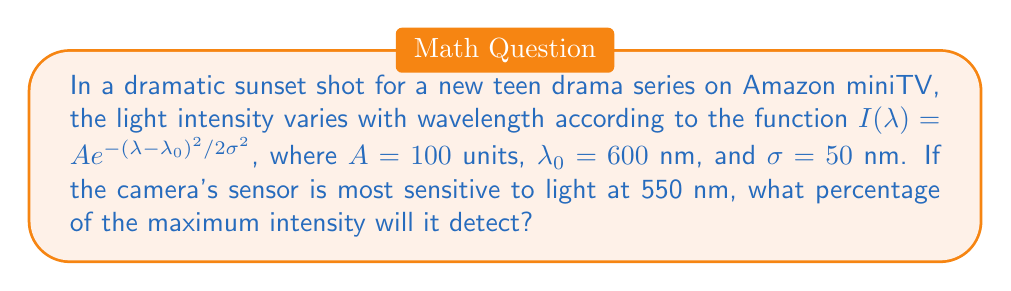Provide a solution to this math problem. Let's approach this step-by-step:

1) The light intensity function is given by:
   $$I(\lambda) = A e^{-(\lambda - \lambda_0)^2 / 2\sigma^2}$$

2) We're given:
   $A = 100$ units
   $\lambda_0 = 600$ nm
   $\sigma = 50$ nm

3) The camera is most sensitive at $\lambda = 550$ nm

4) To find the intensity at 550 nm, we substitute these values into the equation:
   $$I(550) = 100 e^{-(550 - 600)^2 / 2(50)^2}$$

5) Simplify inside the exponent:
   $$I(550) = 100 e^{-(-50)^2 / 2(2500)}$$
   $$I(550) = 100 e^{-2500 / 5000}$$
   $$I(550) = 100 e^{-0.5}$$

6) Calculate:
   $$I(550) = 100 \cdot 0.6065 = 60.65$$

7) The maximum intensity occurs at $\lambda_0 = 600$ nm:
   $$I(600) = 100 e^{-(600 - 600)^2 / 2(50)^2} = 100$$

8) To get the percentage, divide and multiply by 100:
   $$\text{Percentage} = \frac{60.65}{100} \cdot 100\% = 60.65\%$$
Answer: 60.65% 